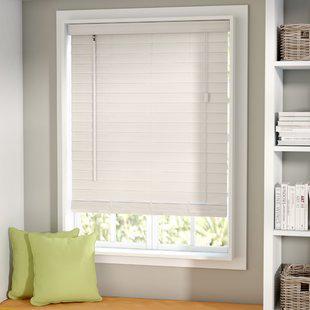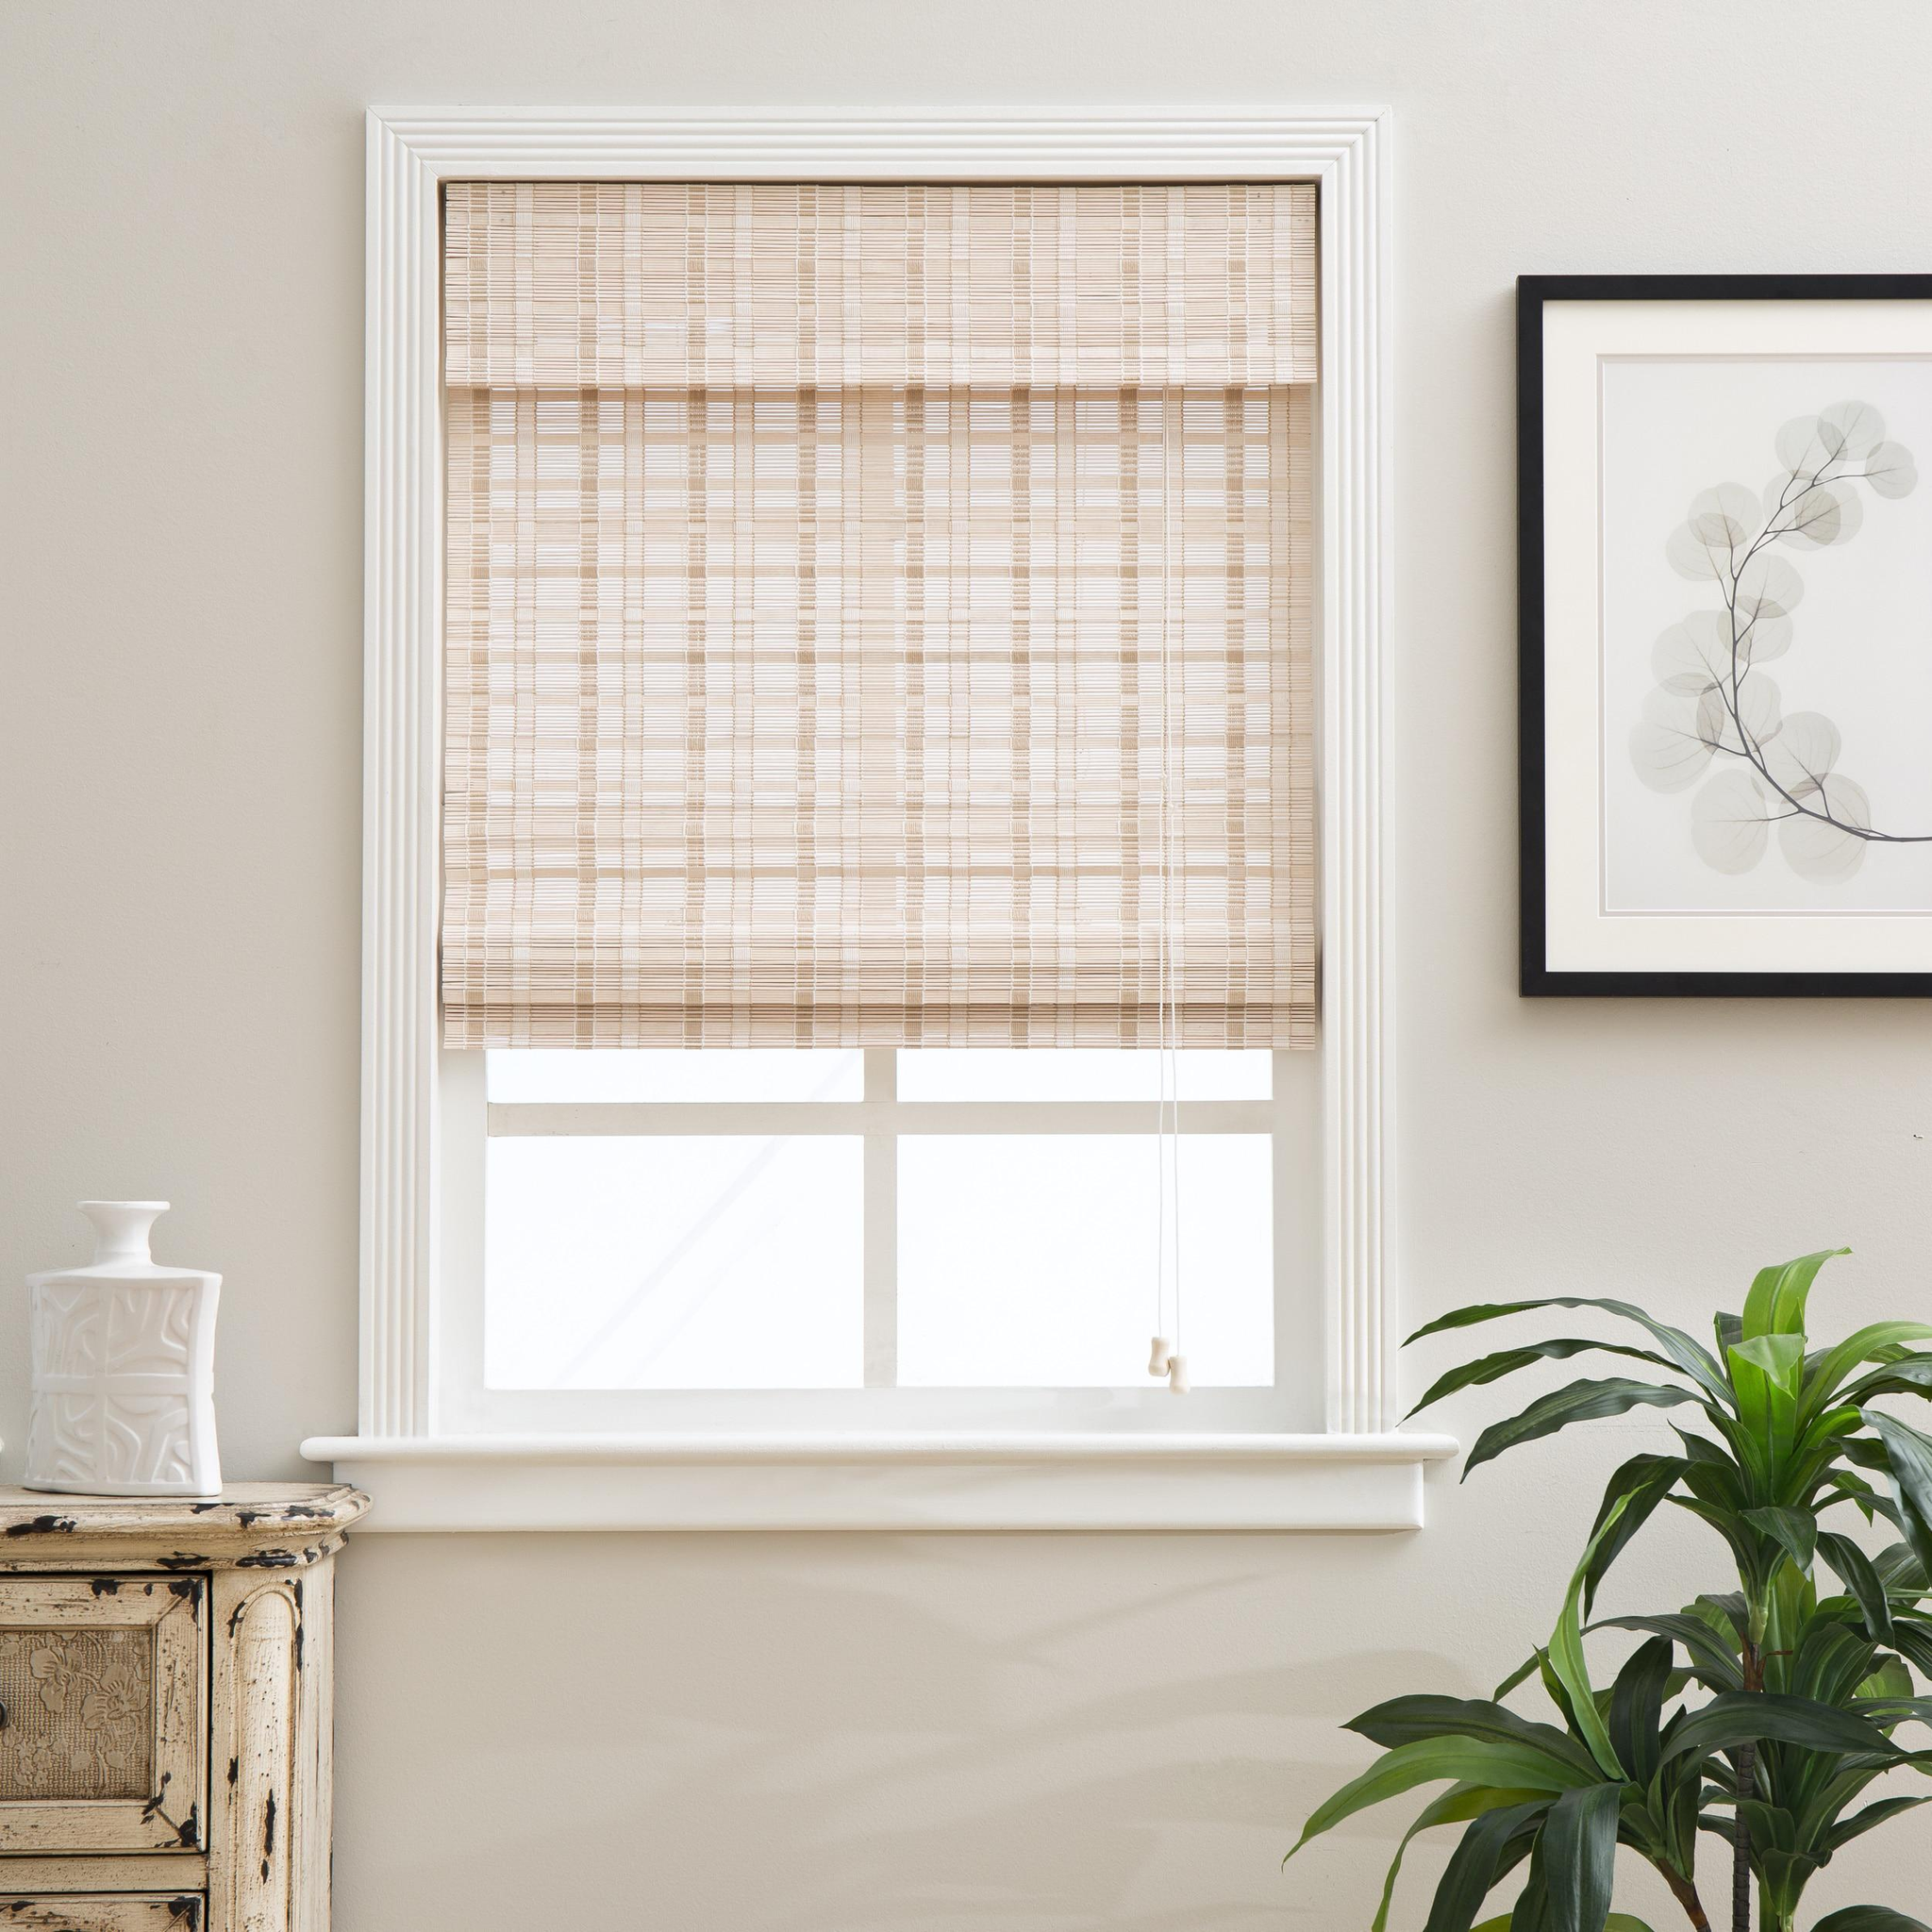The first image is the image on the left, the second image is the image on the right. Given the left and right images, does the statement "The left and right image contains the same number of blinds." hold true? Answer yes or no. Yes. The first image is the image on the left, the second image is the image on the right. Evaluate the accuracy of this statement regarding the images: "All of the window blinds are only partially open.". Is it true? Answer yes or no. Yes. 